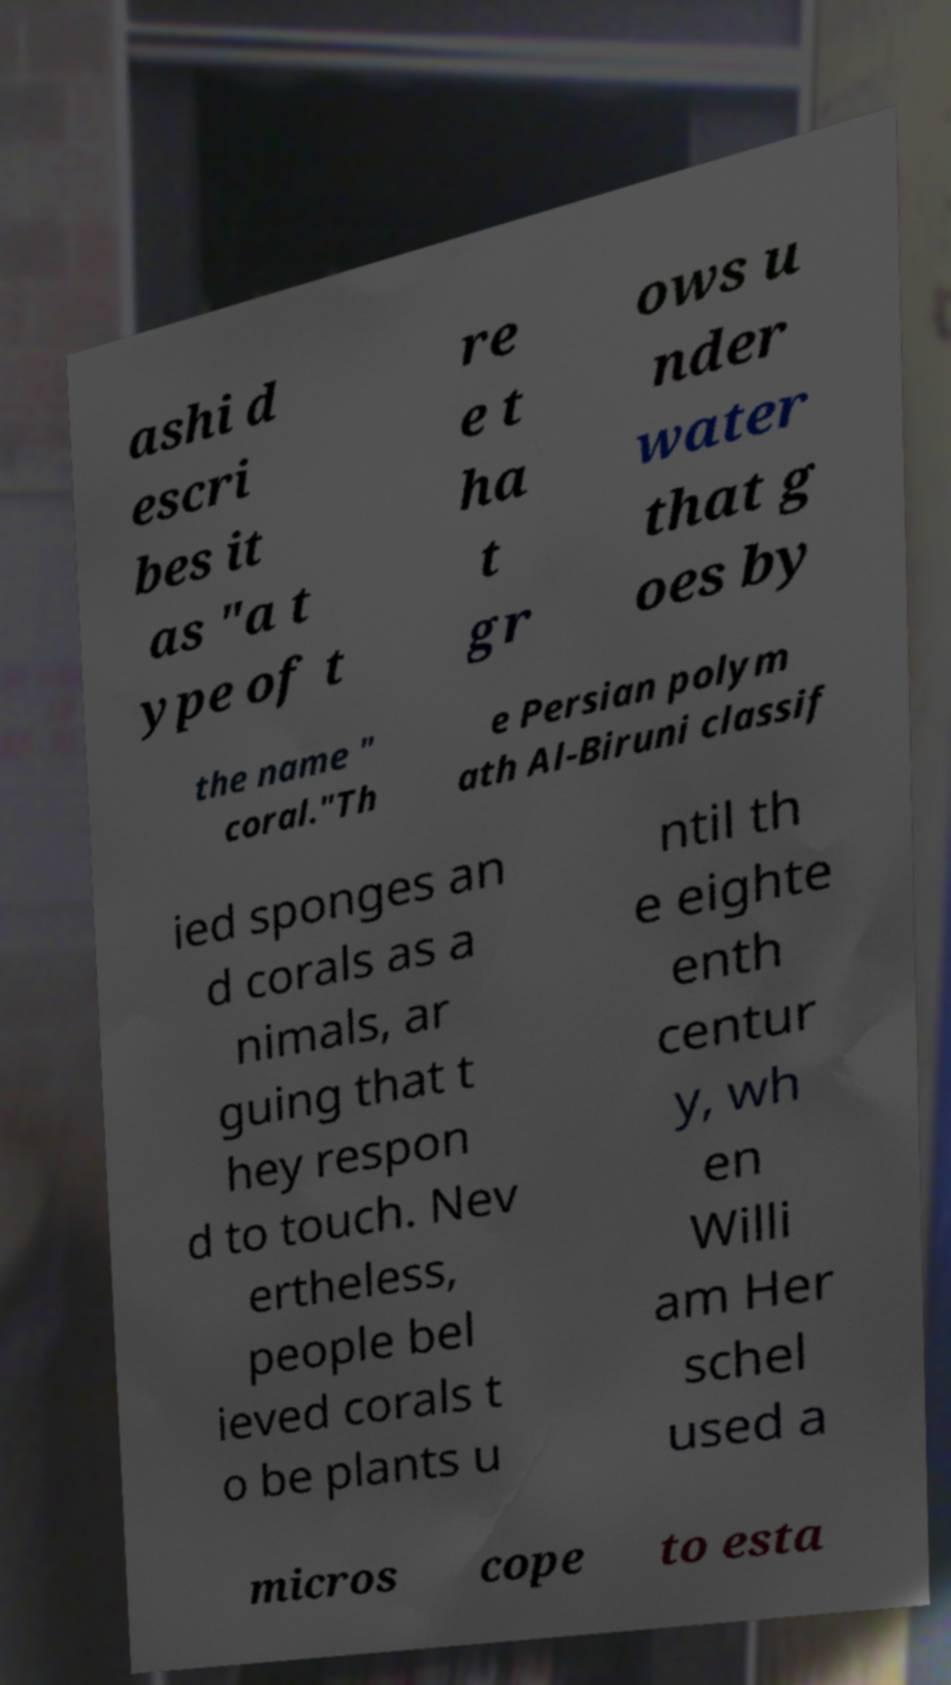Please identify and transcribe the text found in this image. ashi d escri bes it as "a t ype of t re e t ha t gr ows u nder water that g oes by the name " coral."Th e Persian polym ath Al-Biruni classif ied sponges an d corals as a nimals, ar guing that t hey respon d to touch. Nev ertheless, people bel ieved corals t o be plants u ntil th e eighte enth centur y, wh en Willi am Her schel used a micros cope to esta 